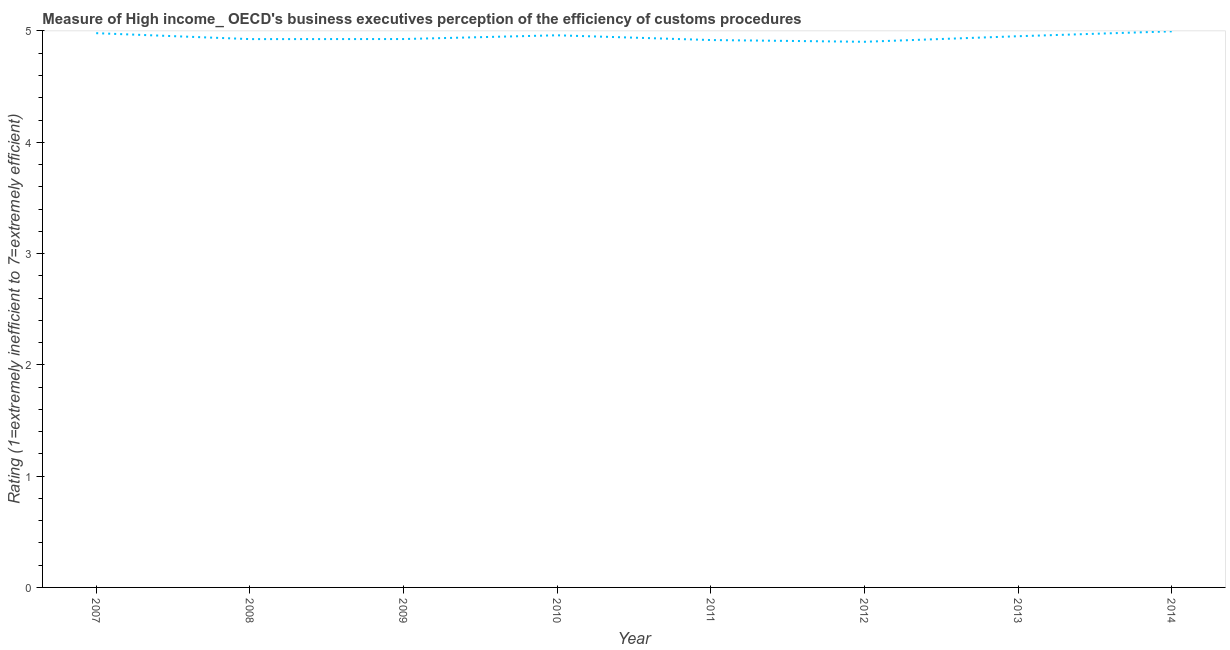What is the rating measuring burden of customs procedure in 2014?
Give a very brief answer. 5. Across all years, what is the maximum rating measuring burden of customs procedure?
Give a very brief answer. 5. Across all years, what is the minimum rating measuring burden of customs procedure?
Your answer should be very brief. 4.9. In which year was the rating measuring burden of customs procedure minimum?
Your answer should be compact. 2012. What is the sum of the rating measuring burden of customs procedure?
Keep it short and to the point. 39.57. What is the difference between the rating measuring burden of customs procedure in 2009 and 2013?
Offer a very short reply. -0.03. What is the average rating measuring burden of customs procedure per year?
Offer a terse response. 4.95. What is the median rating measuring burden of customs procedure?
Keep it short and to the point. 4.94. What is the ratio of the rating measuring burden of customs procedure in 2007 to that in 2012?
Your answer should be compact. 1.02. What is the difference between the highest and the second highest rating measuring burden of customs procedure?
Make the answer very short. 0.02. Is the sum of the rating measuring burden of customs procedure in 2008 and 2011 greater than the maximum rating measuring burden of customs procedure across all years?
Make the answer very short. Yes. What is the difference between the highest and the lowest rating measuring burden of customs procedure?
Ensure brevity in your answer.  0.09. How many years are there in the graph?
Give a very brief answer. 8. Does the graph contain any zero values?
Make the answer very short. No. What is the title of the graph?
Ensure brevity in your answer.  Measure of High income_ OECD's business executives perception of the efficiency of customs procedures. What is the label or title of the Y-axis?
Offer a very short reply. Rating (1=extremely inefficient to 7=extremely efficient). What is the Rating (1=extremely inefficient to 7=extremely efficient) of 2007?
Give a very brief answer. 4.98. What is the Rating (1=extremely inefficient to 7=extremely efficient) of 2008?
Your answer should be very brief. 4.93. What is the Rating (1=extremely inefficient to 7=extremely efficient) in 2009?
Keep it short and to the point. 4.93. What is the Rating (1=extremely inefficient to 7=extremely efficient) in 2010?
Offer a terse response. 4.96. What is the Rating (1=extremely inefficient to 7=extremely efficient) in 2011?
Offer a very short reply. 4.92. What is the Rating (1=extremely inefficient to 7=extremely efficient) of 2012?
Your response must be concise. 4.9. What is the Rating (1=extremely inefficient to 7=extremely efficient) in 2013?
Provide a succinct answer. 4.95. What is the Rating (1=extremely inefficient to 7=extremely efficient) of 2014?
Ensure brevity in your answer.  5. What is the difference between the Rating (1=extremely inefficient to 7=extremely efficient) in 2007 and 2008?
Provide a succinct answer. 0.05. What is the difference between the Rating (1=extremely inefficient to 7=extremely efficient) in 2007 and 2009?
Offer a very short reply. 0.05. What is the difference between the Rating (1=extremely inefficient to 7=extremely efficient) in 2007 and 2010?
Offer a very short reply. 0.02. What is the difference between the Rating (1=extremely inefficient to 7=extremely efficient) in 2007 and 2011?
Your response must be concise. 0.06. What is the difference between the Rating (1=extremely inefficient to 7=extremely efficient) in 2007 and 2012?
Ensure brevity in your answer.  0.08. What is the difference between the Rating (1=extremely inefficient to 7=extremely efficient) in 2007 and 2013?
Provide a short and direct response. 0.03. What is the difference between the Rating (1=extremely inefficient to 7=extremely efficient) in 2007 and 2014?
Ensure brevity in your answer.  -0.02. What is the difference between the Rating (1=extremely inefficient to 7=extremely efficient) in 2008 and 2009?
Your response must be concise. -0. What is the difference between the Rating (1=extremely inefficient to 7=extremely efficient) in 2008 and 2010?
Provide a short and direct response. -0.03. What is the difference between the Rating (1=extremely inefficient to 7=extremely efficient) in 2008 and 2011?
Make the answer very short. 0.01. What is the difference between the Rating (1=extremely inefficient to 7=extremely efficient) in 2008 and 2012?
Ensure brevity in your answer.  0.02. What is the difference between the Rating (1=extremely inefficient to 7=extremely efficient) in 2008 and 2013?
Ensure brevity in your answer.  -0.03. What is the difference between the Rating (1=extremely inefficient to 7=extremely efficient) in 2008 and 2014?
Ensure brevity in your answer.  -0.07. What is the difference between the Rating (1=extremely inefficient to 7=extremely efficient) in 2009 and 2010?
Offer a very short reply. -0.03. What is the difference between the Rating (1=extremely inefficient to 7=extremely efficient) in 2009 and 2011?
Ensure brevity in your answer.  0.01. What is the difference between the Rating (1=extremely inefficient to 7=extremely efficient) in 2009 and 2012?
Your response must be concise. 0.02. What is the difference between the Rating (1=extremely inefficient to 7=extremely efficient) in 2009 and 2013?
Make the answer very short. -0.03. What is the difference between the Rating (1=extremely inefficient to 7=extremely efficient) in 2009 and 2014?
Your answer should be very brief. -0.07. What is the difference between the Rating (1=extremely inefficient to 7=extremely efficient) in 2010 and 2011?
Offer a very short reply. 0.04. What is the difference between the Rating (1=extremely inefficient to 7=extremely efficient) in 2010 and 2012?
Your answer should be compact. 0.06. What is the difference between the Rating (1=extremely inefficient to 7=extremely efficient) in 2010 and 2013?
Provide a succinct answer. 0.01. What is the difference between the Rating (1=extremely inefficient to 7=extremely efficient) in 2010 and 2014?
Provide a succinct answer. -0.04. What is the difference between the Rating (1=extremely inefficient to 7=extremely efficient) in 2011 and 2012?
Ensure brevity in your answer.  0.02. What is the difference between the Rating (1=extremely inefficient to 7=extremely efficient) in 2011 and 2013?
Your answer should be very brief. -0.03. What is the difference between the Rating (1=extremely inefficient to 7=extremely efficient) in 2011 and 2014?
Provide a short and direct response. -0.08. What is the difference between the Rating (1=extremely inefficient to 7=extremely efficient) in 2012 and 2014?
Your answer should be very brief. -0.09. What is the difference between the Rating (1=extremely inefficient to 7=extremely efficient) in 2013 and 2014?
Ensure brevity in your answer.  -0.04. What is the ratio of the Rating (1=extremely inefficient to 7=extremely efficient) in 2007 to that in 2009?
Your answer should be very brief. 1.01. What is the ratio of the Rating (1=extremely inefficient to 7=extremely efficient) in 2007 to that in 2012?
Give a very brief answer. 1.02. What is the ratio of the Rating (1=extremely inefficient to 7=extremely efficient) in 2008 to that in 2010?
Offer a very short reply. 0.99. What is the ratio of the Rating (1=extremely inefficient to 7=extremely efficient) in 2008 to that in 2011?
Provide a succinct answer. 1. What is the ratio of the Rating (1=extremely inefficient to 7=extremely efficient) in 2009 to that in 2010?
Give a very brief answer. 0.99. What is the ratio of the Rating (1=extremely inefficient to 7=extremely efficient) in 2009 to that in 2011?
Your answer should be very brief. 1. What is the ratio of the Rating (1=extremely inefficient to 7=extremely efficient) in 2010 to that in 2012?
Your response must be concise. 1.01. What is the ratio of the Rating (1=extremely inefficient to 7=extremely efficient) in 2012 to that in 2014?
Give a very brief answer. 0.98. What is the ratio of the Rating (1=extremely inefficient to 7=extremely efficient) in 2013 to that in 2014?
Offer a very short reply. 0.99. 